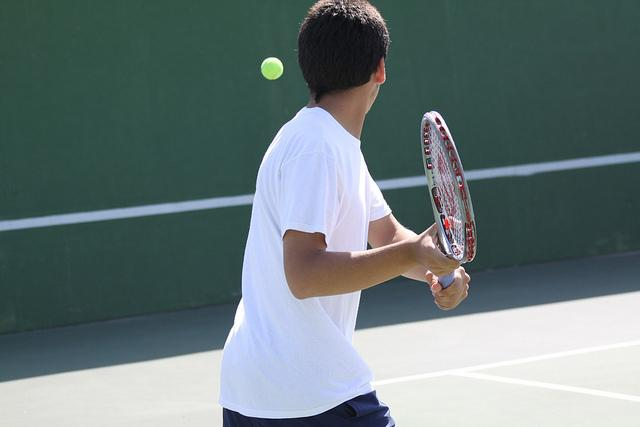What kind of strike is he preparing to do? backhand 